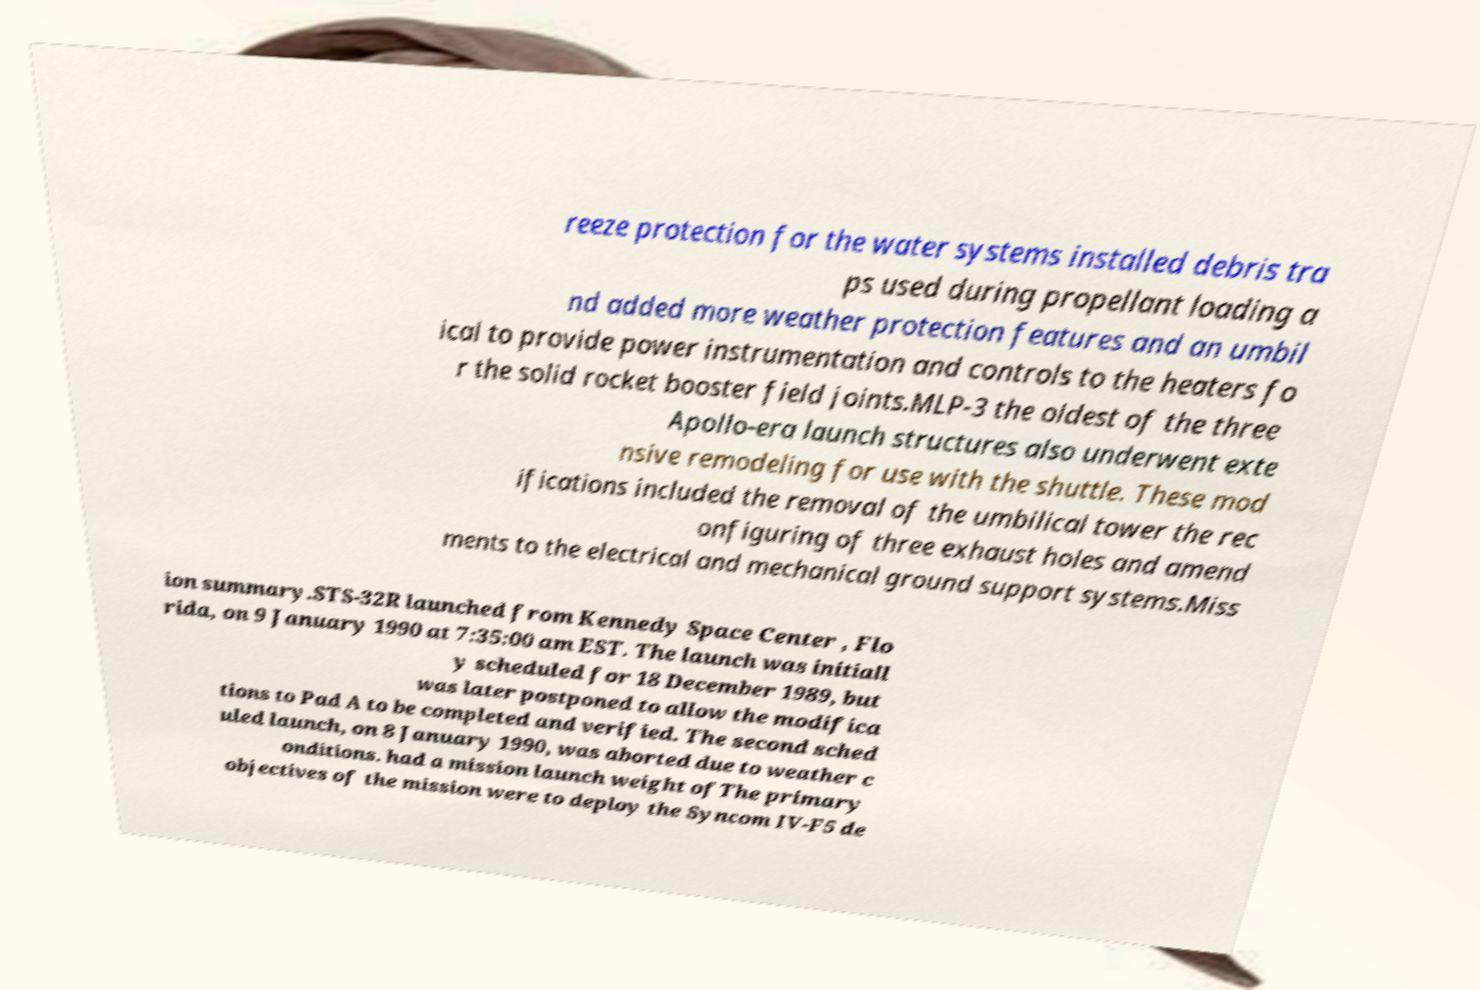There's text embedded in this image that I need extracted. Can you transcribe it verbatim? reeze protection for the water systems installed debris tra ps used during propellant loading a nd added more weather protection features and an umbil ical to provide power instrumentation and controls to the heaters fo r the solid rocket booster field joints.MLP-3 the oldest of the three Apollo-era launch structures also underwent exte nsive remodeling for use with the shuttle. These mod ifications included the removal of the umbilical tower the rec onfiguring of three exhaust holes and amend ments to the electrical and mechanical ground support systems.Miss ion summary.STS-32R launched from Kennedy Space Center , Flo rida, on 9 January 1990 at 7:35:00 am EST. The launch was initiall y scheduled for 18 December 1989, but was later postponed to allow the modifica tions to Pad A to be completed and verified. The second sched uled launch, on 8 January 1990, was aborted due to weather c onditions. had a mission launch weight ofThe primary objectives of the mission were to deploy the Syncom IV-F5 de 